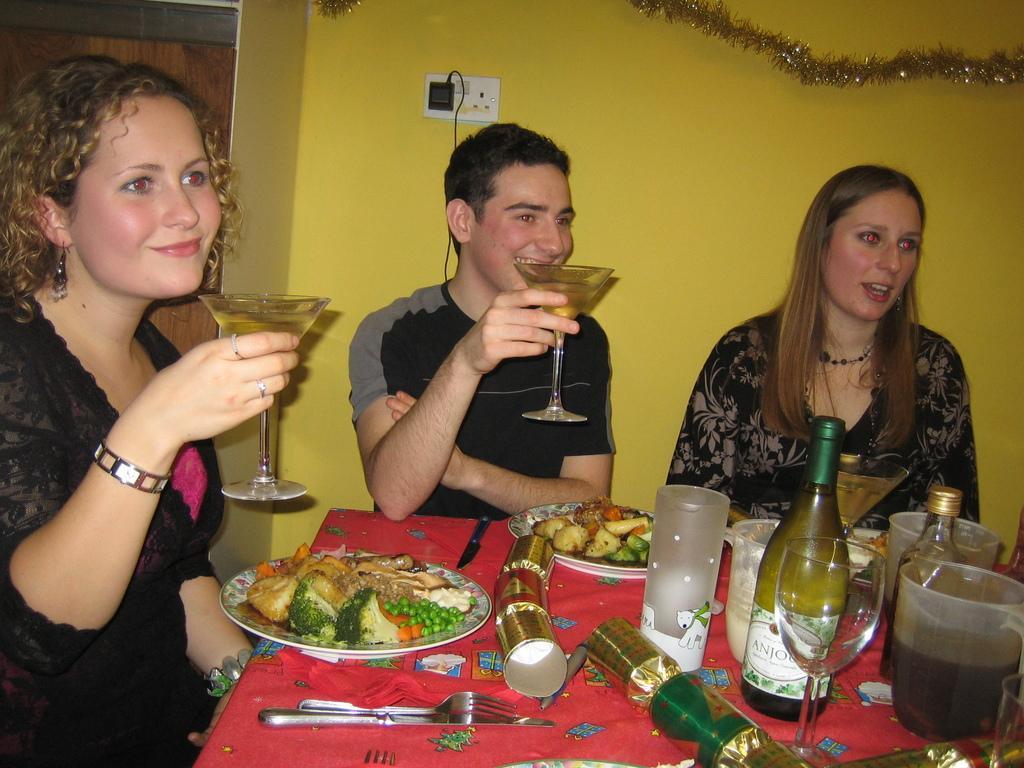Describe this image in one or two sentences. In this image I see 2 women and a man and I see all of them are smiling and I can also see these are holding glasses in their hands and there is a table in front of them on which there are bottles, mugs, plates full of food, knife, fork, glass and other things. In the background I see the wall, decoration and a charger. 